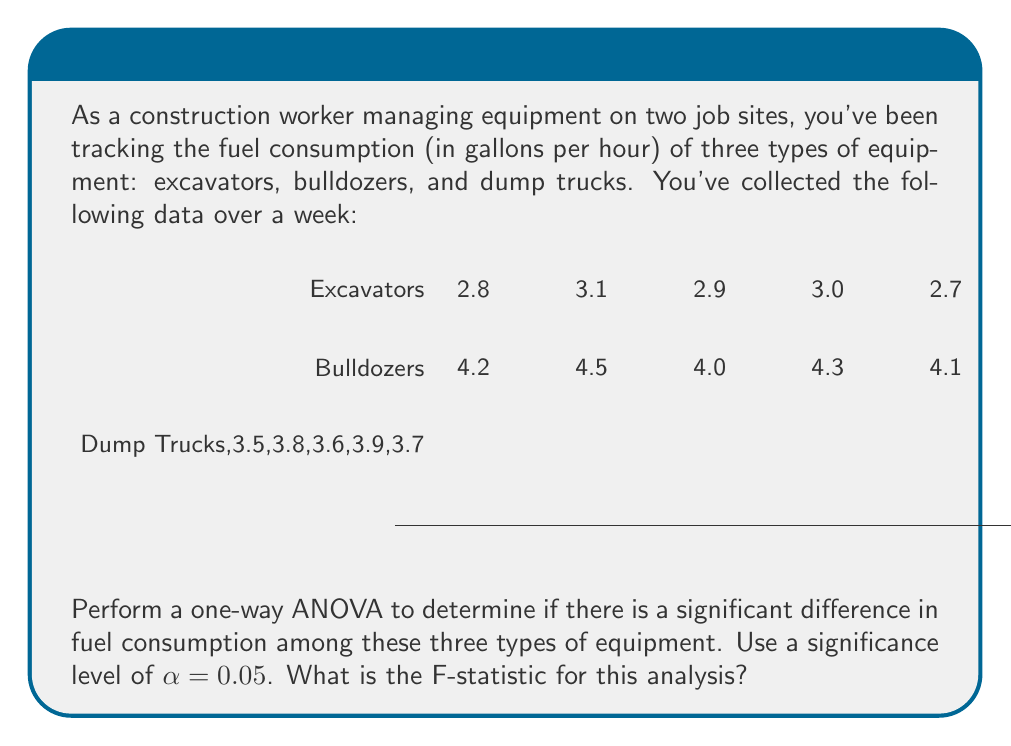Provide a solution to this math problem. Let's perform the one-way ANOVA step-by-step:

1) Calculate the means for each group:
   Excavators: $\bar{X}_1 = \frac{2.8 + 3.1 + 2.9 + 3.0 + 2.7}{5} = 2.9$
   Bulldozers: $\bar{X}_2 = \frac{4.2 + 4.5 + 4.0 + 4.3 + 4.1}{5} = 4.22$
   Dump Trucks: $\bar{X}_3 = \frac{3.5 + 3.8 + 3.6 + 3.9 + 3.7}{5} = 3.7$

2) Calculate the grand mean:
   $\bar{X} = \frac{2.9 + 4.22 + 3.7}{3} = 3.61$

3) Calculate the Sum of Squares Between (SSB):
   SSB = $5[(2.9 - 3.61)^2 + (4.22 - 3.61)^2 + (3.7 - 3.61)^2] = 4.5442$

4) Calculate the Sum of Squares Within (SSW):
   SSW = $(2.8 - 2.9)^2 + (3.1 - 2.9)^2 + ... + (3.9 - 3.7)^2 + (3.7 - 3.7)^2 = 0.48$

5) Calculate the degrees of freedom:
   df(between) = 3 - 1 = 2
   df(within) = 15 - 3 = 12
   df(total) = 15 - 1 = 14

6) Calculate the Mean Square Between (MSB) and Mean Square Within (MSW):
   MSB = SSB / df(between) = 4.5442 / 2 = 2.2721
   MSW = SSW / df(within) = 0.48 / 12 = 0.04

7) Calculate the F-statistic:
   F = MSB / MSW = 2.2721 / 0.04 = 56.8025

The F-statistic is 56.8025.
Answer: 56.8025 